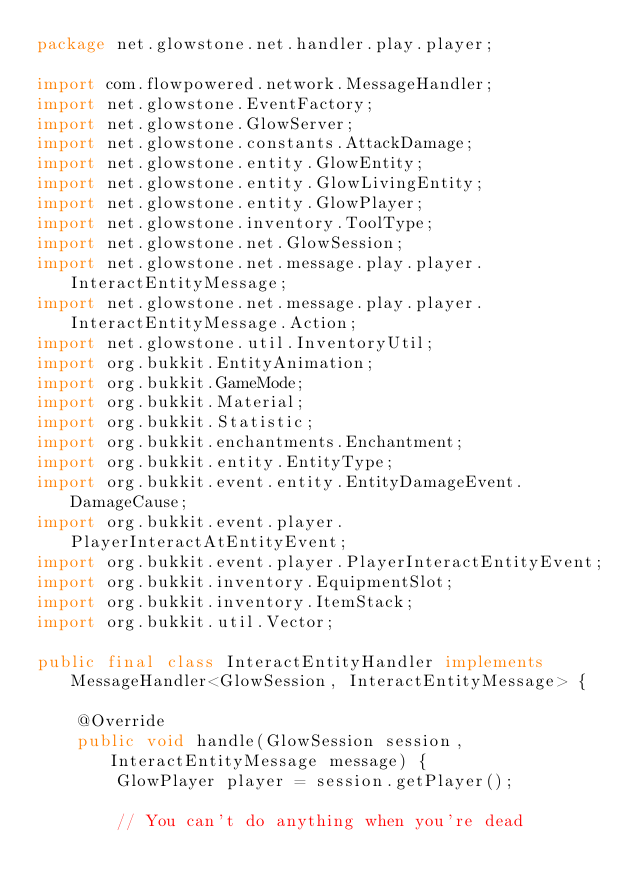<code> <loc_0><loc_0><loc_500><loc_500><_Java_>package net.glowstone.net.handler.play.player;

import com.flowpowered.network.MessageHandler;
import net.glowstone.EventFactory;
import net.glowstone.GlowServer;
import net.glowstone.constants.AttackDamage;
import net.glowstone.entity.GlowEntity;
import net.glowstone.entity.GlowLivingEntity;
import net.glowstone.entity.GlowPlayer;
import net.glowstone.inventory.ToolType;
import net.glowstone.net.GlowSession;
import net.glowstone.net.message.play.player.InteractEntityMessage;
import net.glowstone.net.message.play.player.InteractEntityMessage.Action;
import net.glowstone.util.InventoryUtil;
import org.bukkit.EntityAnimation;
import org.bukkit.GameMode;
import org.bukkit.Material;
import org.bukkit.Statistic;
import org.bukkit.enchantments.Enchantment;
import org.bukkit.entity.EntityType;
import org.bukkit.event.entity.EntityDamageEvent.DamageCause;
import org.bukkit.event.player.PlayerInteractAtEntityEvent;
import org.bukkit.event.player.PlayerInteractEntityEvent;
import org.bukkit.inventory.EquipmentSlot;
import org.bukkit.inventory.ItemStack;
import org.bukkit.util.Vector;

public final class InteractEntityHandler implements MessageHandler<GlowSession, InteractEntityMessage> {

    @Override
    public void handle(GlowSession session, InteractEntityMessage message) {
        GlowPlayer player = session.getPlayer();

        // You can't do anything when you're dead</code> 